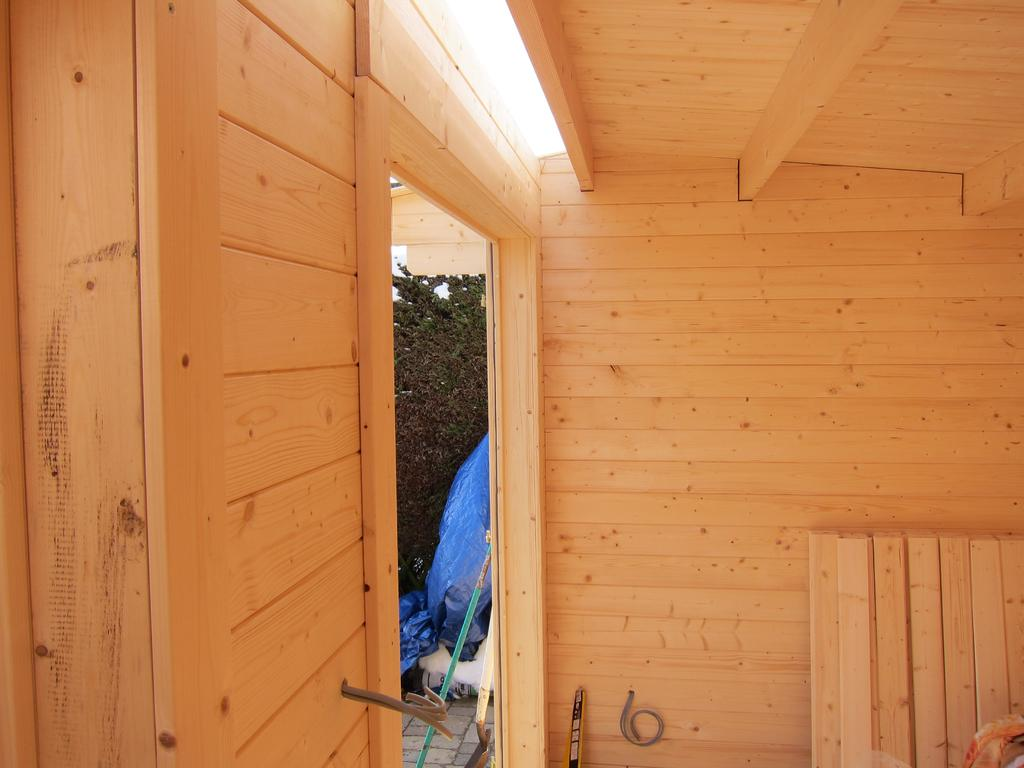What type of material is used for the wall in the image? There is a wooden wall in the image. What type of material is used for the roof in the image? There is a wooden roof in the image. What type of vegetation is visible in the image? There is a tree visible in the image. What is covering the structure in the image? There is a plastic cover in the image. Can you see any flesh or muscles on the tree in the image? No, there is no flesh or muscles visible on the tree in the image. How does the plastic cover touch the wooden roof in the image? The plastic cover does not touch the wooden roof in the image; it is covering the structure from above. 